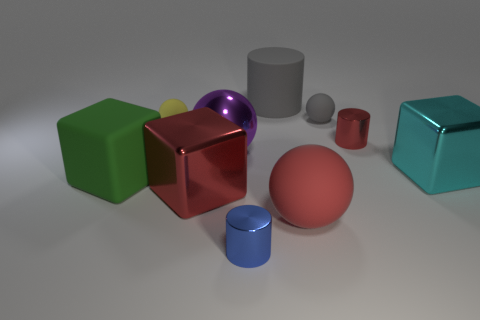Is there anything else that is the same size as the blue metallic cylinder?
Ensure brevity in your answer.  Yes. Are there more large metal cubes that are to the left of the cyan shiny thing than big cyan objects?
Offer a very short reply. No. The big thing on the right side of the red metal object that is on the right side of the tiny metallic cylinder that is in front of the red cylinder is what shape?
Ensure brevity in your answer.  Cube. There is a red shiny thing that is to the right of the blue metallic cylinder; is it the same size as the purple shiny thing?
Offer a terse response. No. What is the shape of the metal thing that is on the right side of the large red matte object and in front of the purple sphere?
Your answer should be very brief. Cube. Do the rubber cylinder and the big sphere right of the big purple thing have the same color?
Offer a very short reply. No. What color is the tiny thing that is behind the tiny matte object that is left of the big gray rubber cylinder behind the big red rubber thing?
Keep it short and to the point. Gray. What is the color of the other big thing that is the same shape as the purple object?
Your response must be concise. Red. Are there the same number of large metallic cubes that are right of the matte cylinder and tiny blue matte cylinders?
Give a very brief answer. No. What number of cubes are either large purple things or rubber objects?
Offer a terse response. 1. 